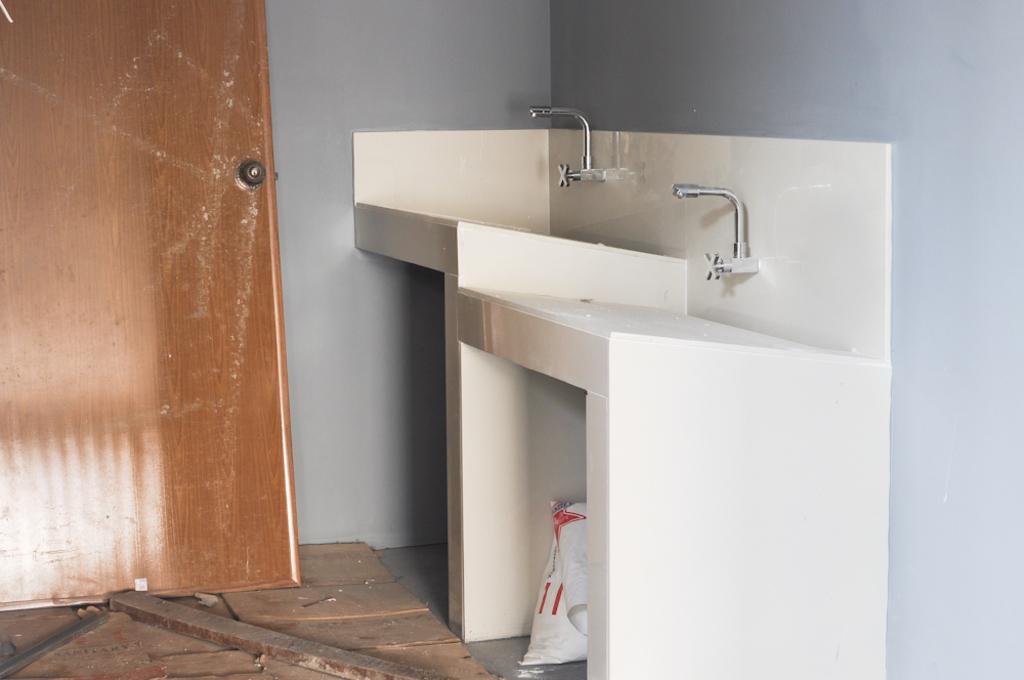Please provide a concise description of this image. This is door, tap and wall. 